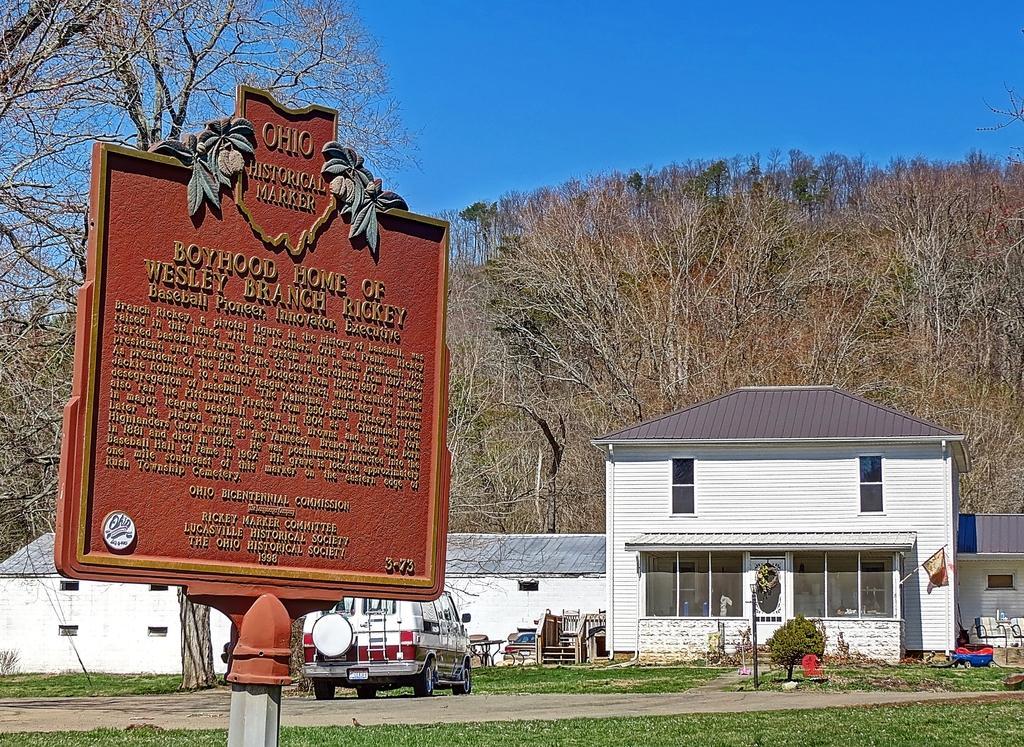Could you give a brief overview of what you see in this image? In front of the picture, we see a board in brown color with some text written on it. At the bottom, we see the grass. Beside that, we see the road. On the left side, we see the trees. In the middle of the picture, we see the buildings in white color with the grey color roofs. Beside that, we see the wooden objects. On the left side, we see a pole and a flag. Beside that, we see an object in blue and red color. There are trees in the background. At the top, we see the sky, which is blue in color. 